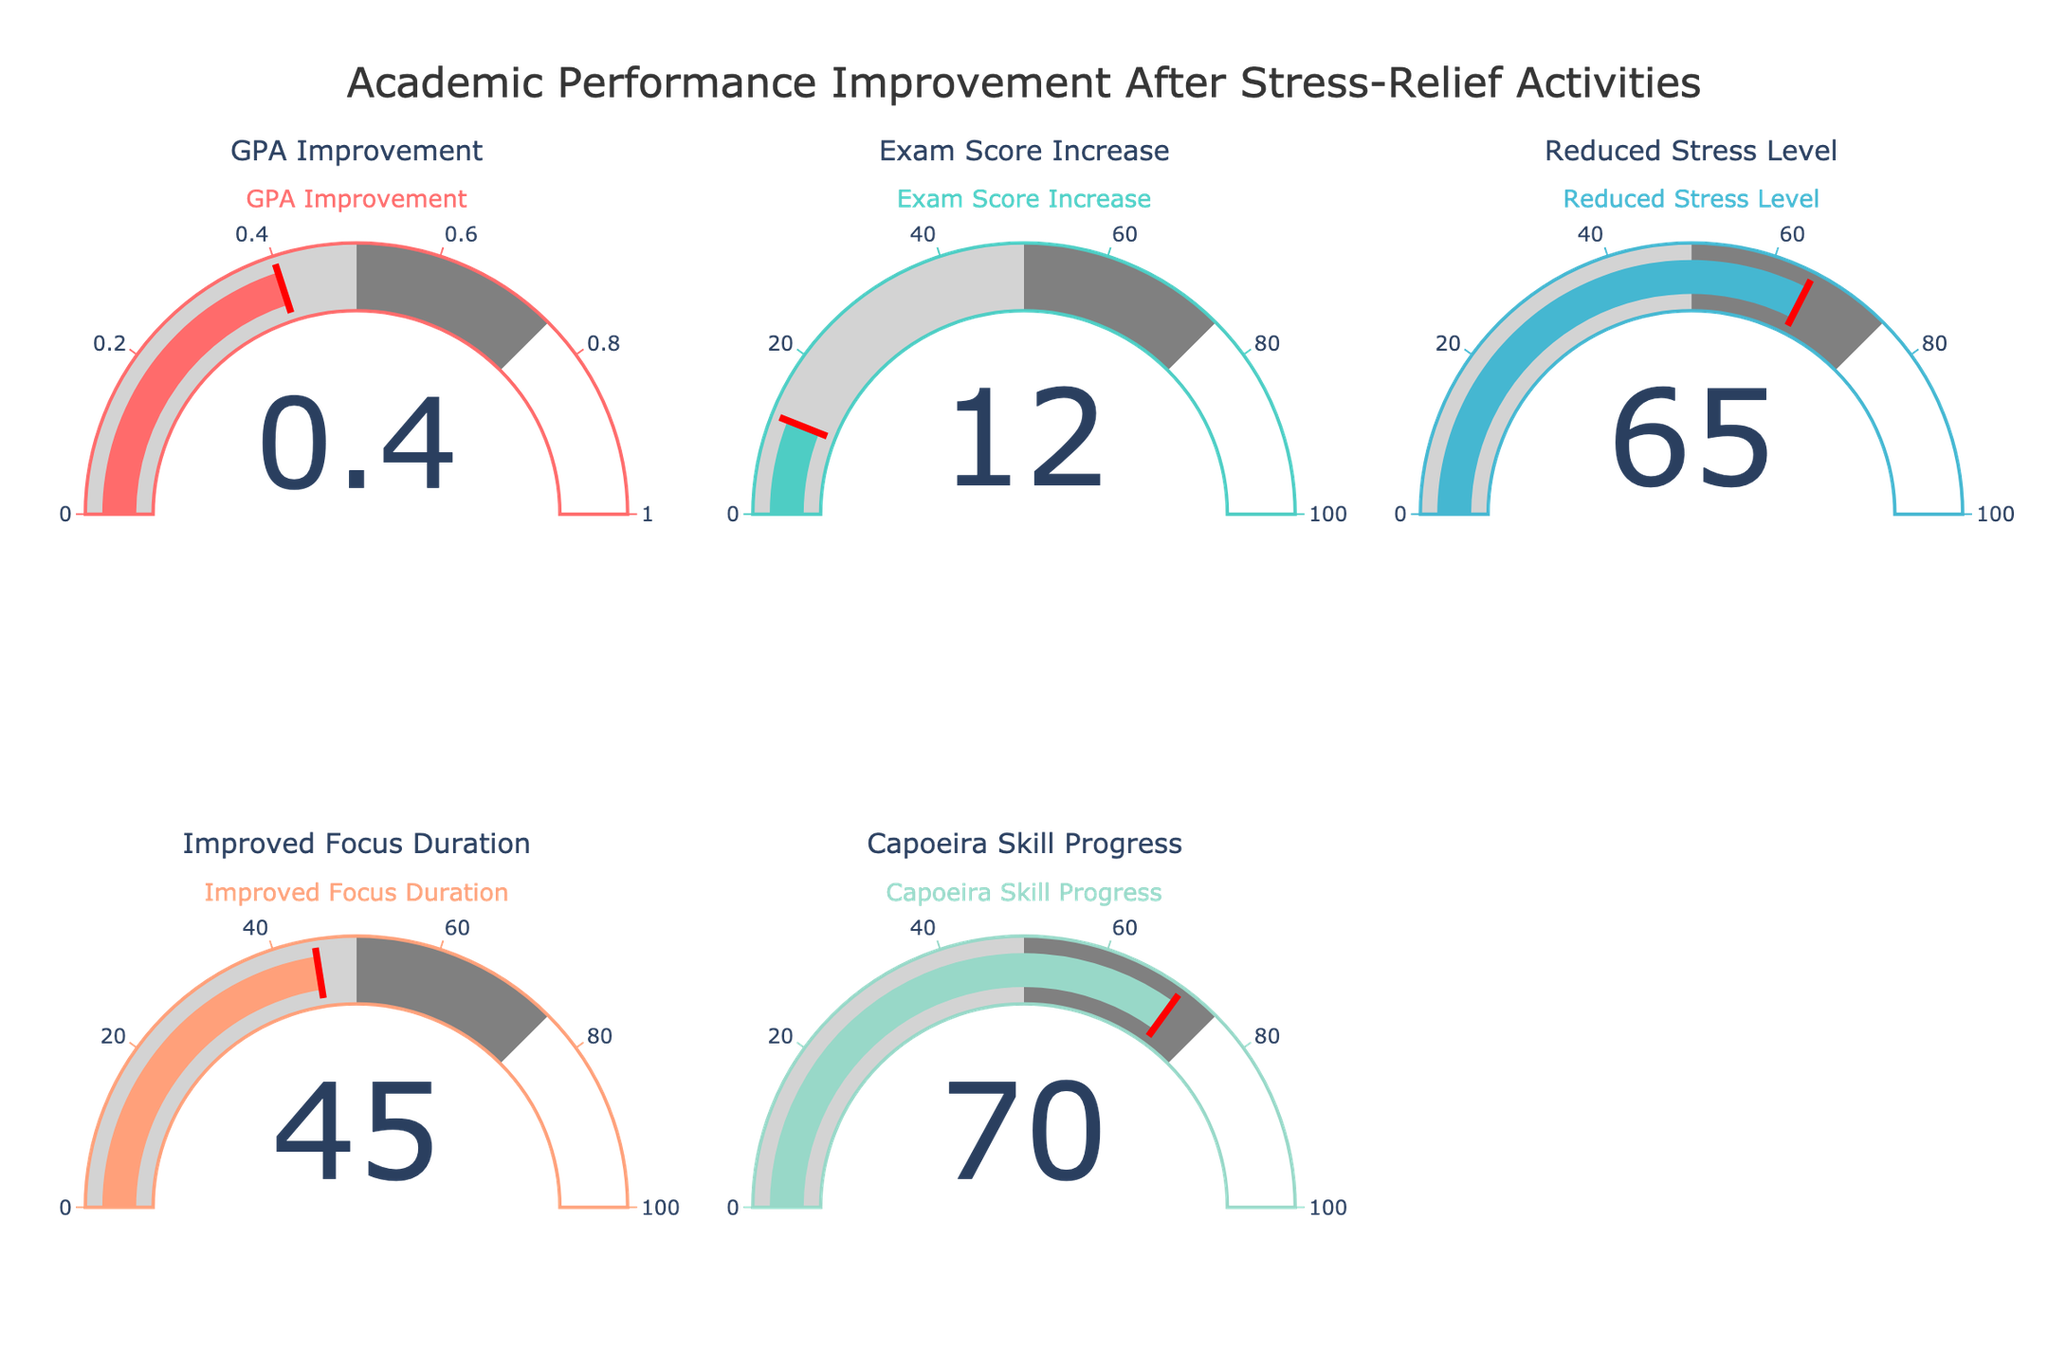What's the title of the figure? The title is prominently displayed at the top of the figure. It reads "Academic Performance Improvement After Stress-Relief Activities".
Answer: Academic Performance Improvement After Stress-Relief Activities What are the colors used in the gauge for 'GPA Improvement'? The 'GPA Improvement' gauge uses shades of red and light gray for the gauge, with red for the threshold line. Specifically, the bar color is a solid shade of red.
Answer: Red, light gray Which metric shows the highest value? To determine this, look at the value displayed on each gauge. The 'Capoeira Skill Progress' metric has the highest value at 70.
Answer: Capoeira Skill Progress How much did exam scores increase? The value shown on the gauge labeled 'Exam Score Increase' indicates how much exam scores have increased. The value displayed is 12.
Answer: 12 What is the improvement in GPA? The improvement in GPA is displayed on the 'GPA Improvement' gauge. The value shown is 0.4.
Answer: 0.4 Compare the values between 'Improved Focus Duration' and 'Reduced Stress Level'. Which one is higher and by how much? The 'Improved Focus Duration' has a value of 45, while the 'Reduced Stress Level' has a value of 65. The 'Reduced Stress Level' is higher by 65 - 45 = 20.
Answer: Reduced Stress Level, by 20 What is the combined value of 'Exam Score Increase' and 'Improved Focus Duration'? The 'Exam Score Increase' is 12 and 'Improved Focus Duration' is 45. Combined, they total 12 + 45 = 57.
Answer: 57 Which metrics have values below 50? By observing each gauge value, 'GPA Improvement' (0.4), 'Exam Score Increase' (12), and 'Improved Focus Duration' (45) are the metrics with values below 50.
Answer: GPA Improvement, Exam Score Increase, Improved Focus Duration What does the gauge with the highest value indicate? The gauge with the highest value is 'Capoeira Skill Progress', and it indicates a value of 70, showing the highest level of improvement in capoeira skills.
Answer: Capoeira Skill Progress 